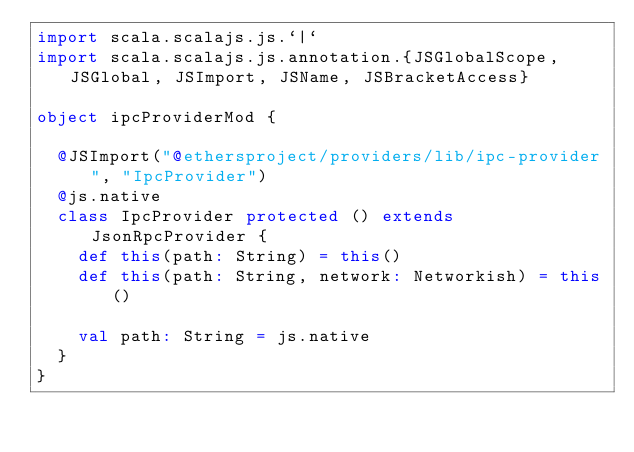<code> <loc_0><loc_0><loc_500><loc_500><_Scala_>import scala.scalajs.js.`|`
import scala.scalajs.js.annotation.{JSGlobalScope, JSGlobal, JSImport, JSName, JSBracketAccess}

object ipcProviderMod {
  
  @JSImport("@ethersproject/providers/lib/ipc-provider", "IpcProvider")
  @js.native
  class IpcProvider protected () extends JsonRpcProvider {
    def this(path: String) = this()
    def this(path: String, network: Networkish) = this()
    
    val path: String = js.native
  }
}
</code> 